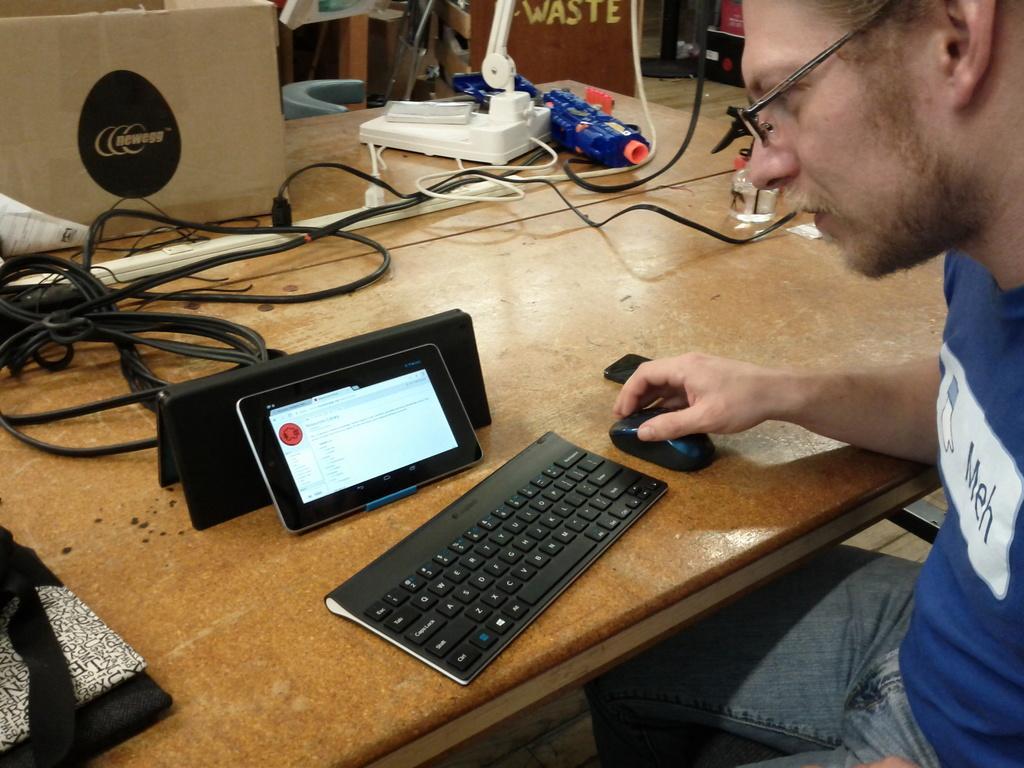Describe this image in one or two sentences. In the middle of the image there is a table, On the table there is a tab, keyboard and mouse. Bottom right side of the image there is a man sitting on a chair. Top left side of the image there are some wires on the table. 